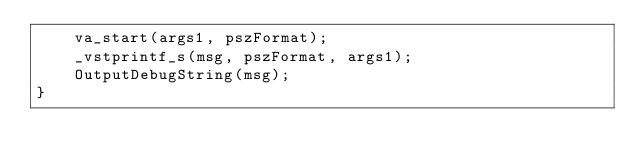Convert code to text. <code><loc_0><loc_0><loc_500><loc_500><_C++_>	va_start(args1, pszFormat);
	_vstprintf_s(msg, pszFormat, args1);
	OutputDebugString(msg);
}
</code> 